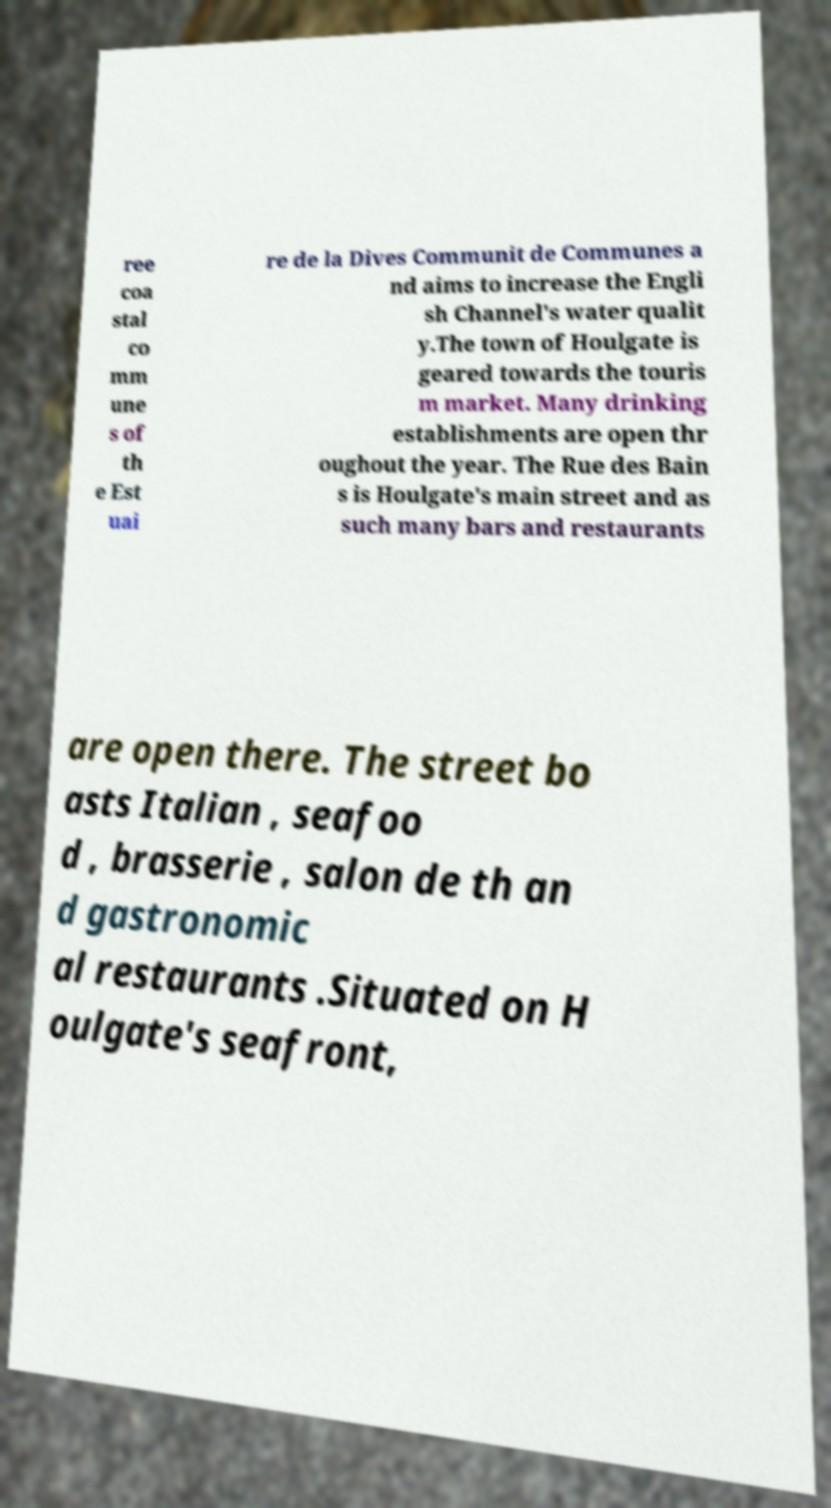For documentation purposes, I need the text within this image transcribed. Could you provide that? ree coa stal co mm une s of th e Est uai re de la Dives Communit de Communes a nd aims to increase the Engli sh Channel's water qualit y.The town of Houlgate is geared towards the touris m market. Many drinking establishments are open thr oughout the year. The Rue des Bain s is Houlgate's main street and as such many bars and restaurants are open there. The street bo asts Italian , seafoo d , brasserie , salon de th an d gastronomic al restaurants .Situated on H oulgate's seafront, 